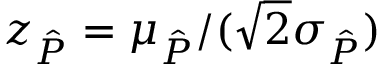Convert formula to latex. <formula><loc_0><loc_0><loc_500><loc_500>z _ { \hat { P } } = \mu _ { \hat { P } } / ( \sqrt { 2 } \sigma _ { \hat { P } } )</formula> 